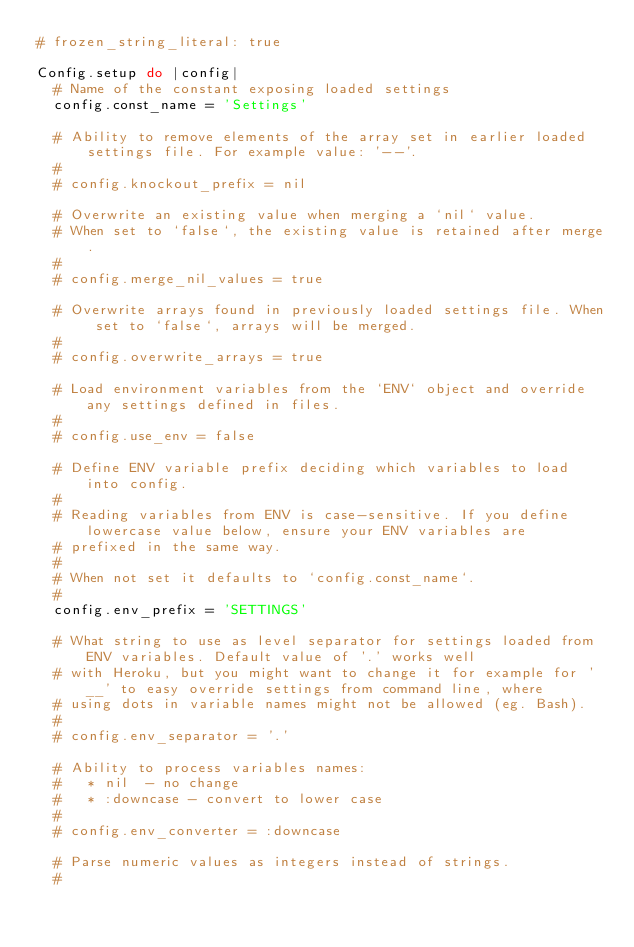Convert code to text. <code><loc_0><loc_0><loc_500><loc_500><_Ruby_># frozen_string_literal: true

Config.setup do |config|
  # Name of the constant exposing loaded settings
  config.const_name = 'Settings'

  # Ability to remove elements of the array set in earlier loaded settings file. For example value: '--'.
  #
  # config.knockout_prefix = nil

  # Overwrite an existing value when merging a `nil` value.
  # When set to `false`, the existing value is retained after merge.
  #
  # config.merge_nil_values = true

  # Overwrite arrays found in previously loaded settings file. When set to `false`, arrays will be merged.
  #
  # config.overwrite_arrays = true

  # Load environment variables from the `ENV` object and override any settings defined in files.
  #
  # config.use_env = false

  # Define ENV variable prefix deciding which variables to load into config.
  #
  # Reading variables from ENV is case-sensitive. If you define lowercase value below, ensure your ENV variables are
  # prefixed in the same way.
  #
  # When not set it defaults to `config.const_name`.
  #
  config.env_prefix = 'SETTINGS'

  # What string to use as level separator for settings loaded from ENV variables. Default value of '.' works well
  # with Heroku, but you might want to change it for example for '__' to easy override settings from command line, where
  # using dots in variable names might not be allowed (eg. Bash).
  #
  # config.env_separator = '.'

  # Ability to process variables names:
  #   * nil  - no change
  #   * :downcase - convert to lower case
  #
  # config.env_converter = :downcase

  # Parse numeric values as integers instead of strings.
  #</code> 